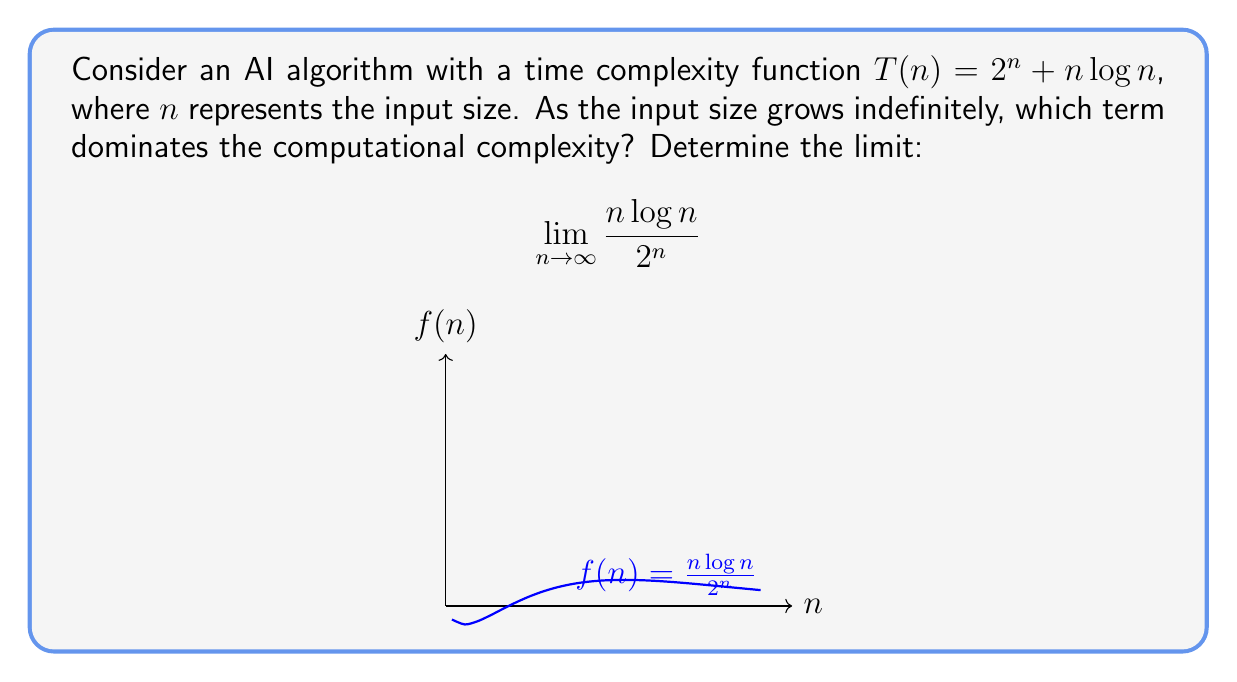Could you help me with this problem? To analyze the limit, we'll use L'Hôpital's rule:

1) First, observe that both the numerator and denominator approach infinity as $n \to \infty$. This is an indeterminate form of type $\frac{\infty}{\infty}$.

2) Apply L'Hôpital's rule by differentiating both numerator and denominator:

   $$\lim_{n \to \infty} \frac{n\log n}{2^n} = \lim_{n \to \infty} \frac{\frac{d}{dn}(n\log n)}{\frac{d}{dn}(2^n)}$$

3) Differentiate:
   - $\frac{d}{dn}(n\log n) = \log n + 1$
   - $\frac{d}{dn}(2^n) = 2^n \ln 2$

4) Substituting back:

   $$\lim_{n \to \infty} \frac{n\log n}{2^n} = \lim_{n \to \infty} \frac{\log n + 1}{2^n \ln 2}$$

5) As $n \to \infty$, $\log n$ grows much slower than $2^n$. Therefore:

   $$\lim_{n \to \infty} \frac{\log n + 1}{2^n \ln 2} = 0$$

6) This implies that as $n$ approaches infinity, $\frac{n\log n}{2^n}$ approaches 0, meaning $2^n$ dominates $n\log n$ in the original complexity function.
Answer: 0; $2^n$ dominates. 